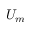Convert formula to latex. <formula><loc_0><loc_0><loc_500><loc_500>U _ { m }</formula> 